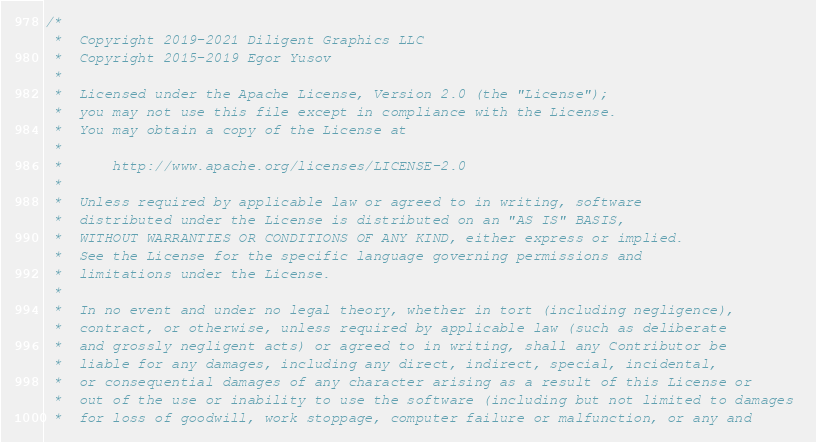<code> <loc_0><loc_0><loc_500><loc_500><_C++_>/*
 *  Copyright 2019-2021 Diligent Graphics LLC
 *  Copyright 2015-2019 Egor Yusov
 *  
 *  Licensed under the Apache License, Version 2.0 (the "License");
 *  you may not use this file except in compliance with the License.
 *  You may obtain a copy of the License at
 *  
 *      http://www.apache.org/licenses/LICENSE-2.0
 *  
 *  Unless required by applicable law or agreed to in writing, software
 *  distributed under the License is distributed on an "AS IS" BASIS,
 *  WITHOUT WARRANTIES OR CONDITIONS OF ANY KIND, either express or implied.
 *  See the License for the specific language governing permissions and
 *  limitations under the License.
 *
 *  In no event and under no legal theory, whether in tort (including negligence), 
 *  contract, or otherwise, unless required by applicable law (such as deliberate 
 *  and grossly negligent acts) or agreed to in writing, shall any Contributor be
 *  liable for any damages, including any direct, indirect, special, incidental, 
 *  or consequential damages of any character arising as a result of this License or 
 *  out of the use or inability to use the software (including but not limited to damages 
 *  for loss of goodwill, work stoppage, computer failure or malfunction, or any and </code> 